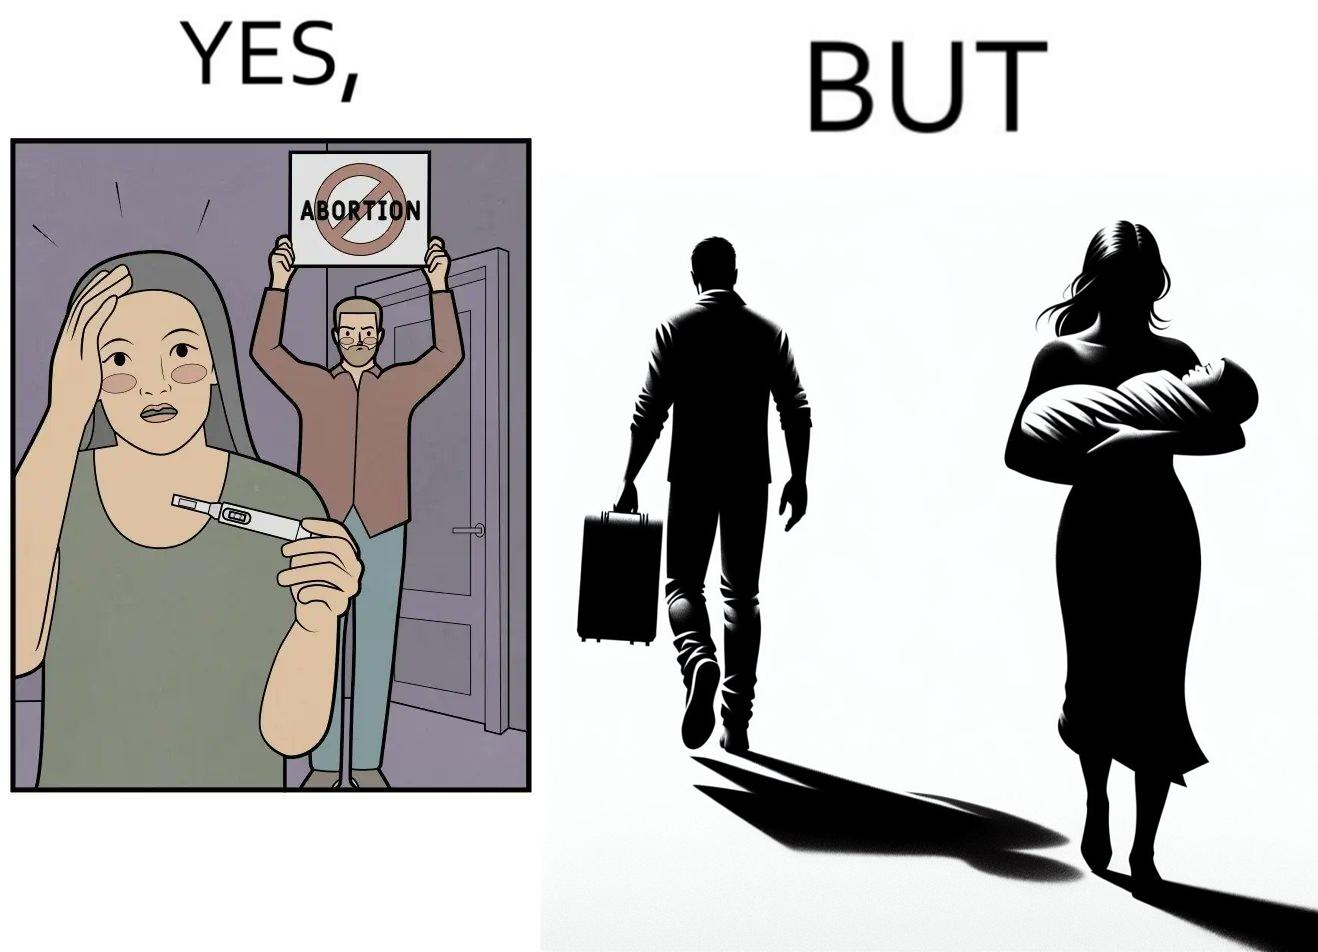Is this a satirical image? Yes, this image is satirical. 